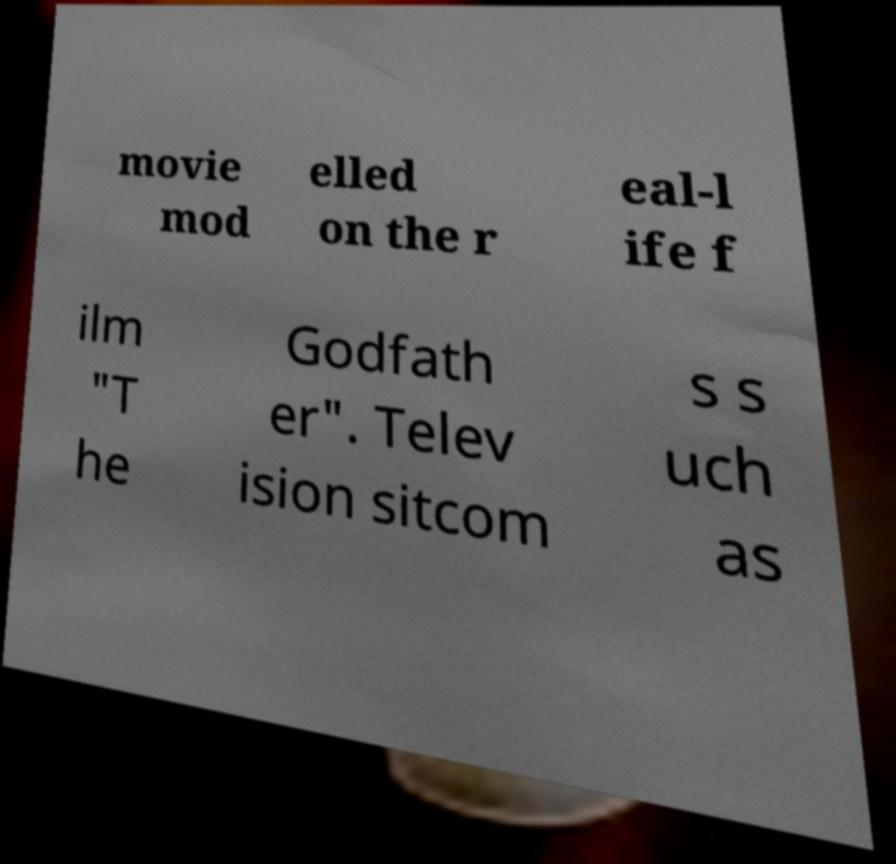Can you accurately transcribe the text from the provided image for me? movie mod elled on the r eal-l ife f ilm "T he Godfath er". Telev ision sitcom s s uch as 